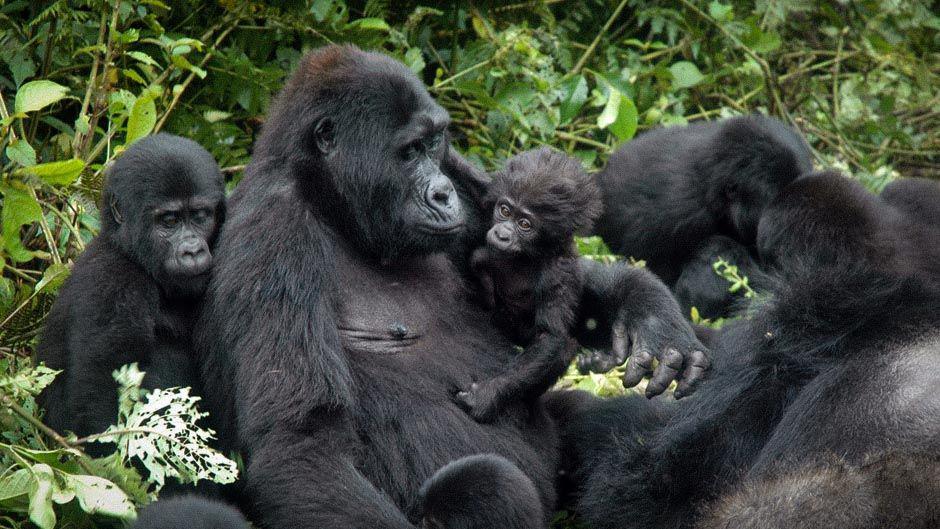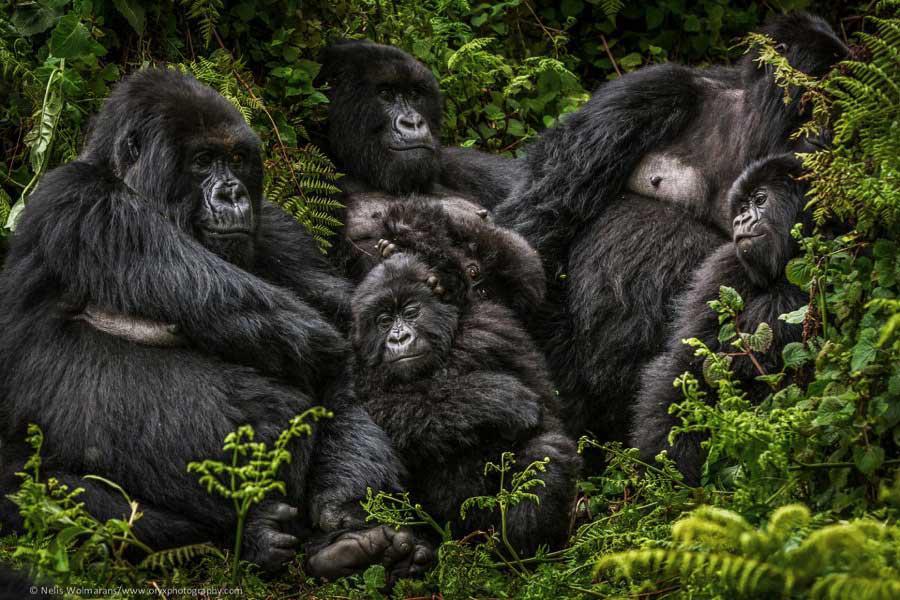The first image is the image on the left, the second image is the image on the right. For the images displayed, is the sentence "An image shows one adult ape, which is touching some part of its head with one hand." factually correct? Answer yes or no. No. The first image is the image on the left, the second image is the image on the right. Considering the images on both sides, is "At least one of the images contains exactly one gorilla." valid? Answer yes or no. No. 